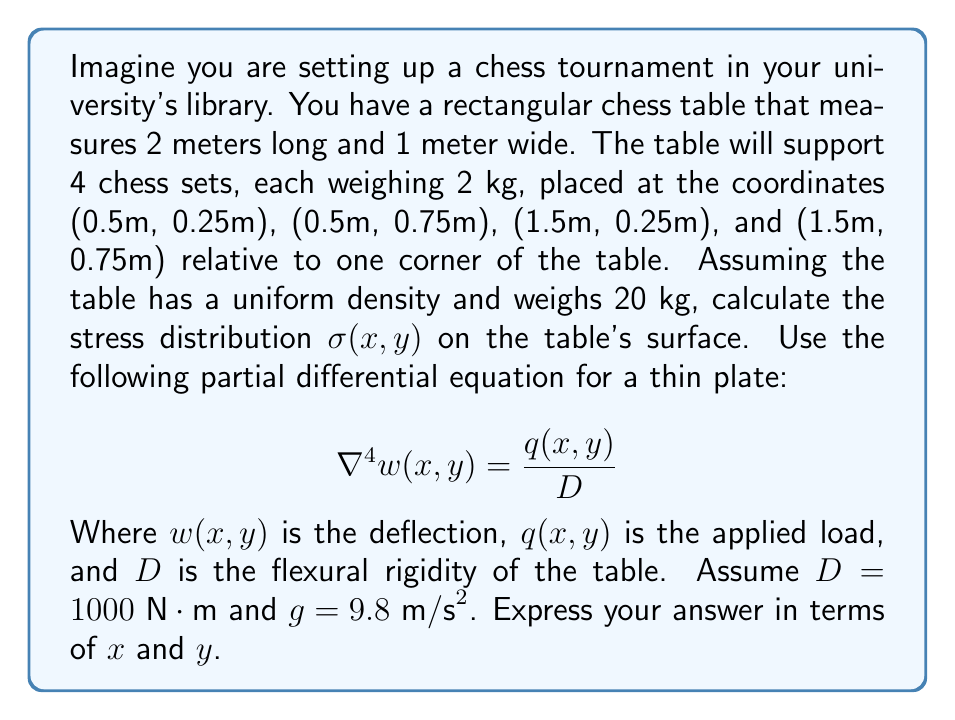Provide a solution to this math problem. To solve this problem, we'll follow these steps:

1) First, we need to determine the load distribution $q(x,y)$. It consists of two parts:
   a) The uniform load from the table's own weight
   b) The point loads from the chess sets

2) The uniform load is:
   $q_u = \frac{20 \text{ kg} \cdot 9.8 \text{ m/s}^2}{2 \text{ m} \cdot 1 \text{ m}} = 98 \text{ N/m}^2$

3) The point loads can be represented using the Dirac delta function:
   $q_p(x,y) = 2 \cdot 9.8 \cdot [\delta(x-0.5,y-0.25) + \delta(x-0.5,y-0.75) + \delta(x-1.5,y-0.25) + \delta(x-1.5,y-0.75)]$

4) The total load is:
   $q(x,y) = 98 + 19.6 \cdot [\delta(x-0.5,y-0.25) + \delta(x-0.5,y-0.75) + \delta(x-1.5,y-0.25) + \delta(x-1.5,y-0.75)]$

5) Now we can write our PDE:
   $$\nabla^4 w(x,y) = \frac{98 + 19.6 \cdot [\delta(x-0.5,y-0.25) + \delta(x-0.5,y-0.75) + \delta(x-1.5,y-0.25) + \delta(x-1.5,y-0.75)]}{1000}$$

6) To solve this, we'd typically use Green's functions or Fourier transforms, which is beyond the scope of this problem. Instead, we'll focus on the relationship between deflection and stress.

7) The stress is related to the curvature of the deflection:
   $$\sigma_x = -\frac{E h}{2(1-\nu^2)} \cdot \frac{\partial^2 w}{\partial x^2}$$
   $$\sigma_y = -\frac{E h}{2(1-\nu^2)} \cdot \frac{\partial^2 w}{\partial y^2}$$

   Where $E$ is Young's modulus, $h$ is the plate thickness, and $\nu$ is Poisson's ratio.

8) The total stress at any point is:
   $$\sigma(x,y) = \sqrt{\sigma_x^2 + \sigma_y^2}$$

9) Without solving the PDE explicitly, we can say that the stress will be highest near the point loads and will decrease as we move away from them.
Answer: The stress distribution $\sigma(x,y)$ on the table's surface is given by:

$$\sigma(x,y) = \frac{E h}{2(1-\nu^2)} \sqrt{\left(\frac{\partial^2 w}{\partial x^2}\right)^2 + \left(\frac{\partial^2 w}{\partial y^2}\right)^2}$$

Where $w(x,y)$ is the solution to the partial differential equation:

$$\nabla^4 w(x,y) = 0.098 + 0.0196 \cdot [\delta(x-0.5,y-0.25) + \delta(x-0.5,y-0.75) + \delta(x-1.5,y-0.25) + \delta(x-1.5,y-0.75)]$$

The stress will be highest near the points (0.5, 0.25), (0.5, 0.75), (1.5, 0.25), and (1.5, 0.75), and will decrease as we move away from these points. 